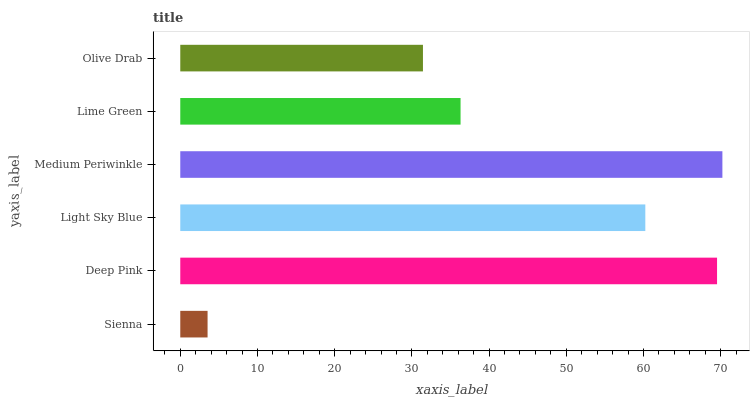Is Sienna the minimum?
Answer yes or no. Yes. Is Medium Periwinkle the maximum?
Answer yes or no. Yes. Is Deep Pink the minimum?
Answer yes or no. No. Is Deep Pink the maximum?
Answer yes or no. No. Is Deep Pink greater than Sienna?
Answer yes or no. Yes. Is Sienna less than Deep Pink?
Answer yes or no. Yes. Is Sienna greater than Deep Pink?
Answer yes or no. No. Is Deep Pink less than Sienna?
Answer yes or no. No. Is Light Sky Blue the high median?
Answer yes or no. Yes. Is Lime Green the low median?
Answer yes or no. Yes. Is Lime Green the high median?
Answer yes or no. No. Is Deep Pink the low median?
Answer yes or no. No. 